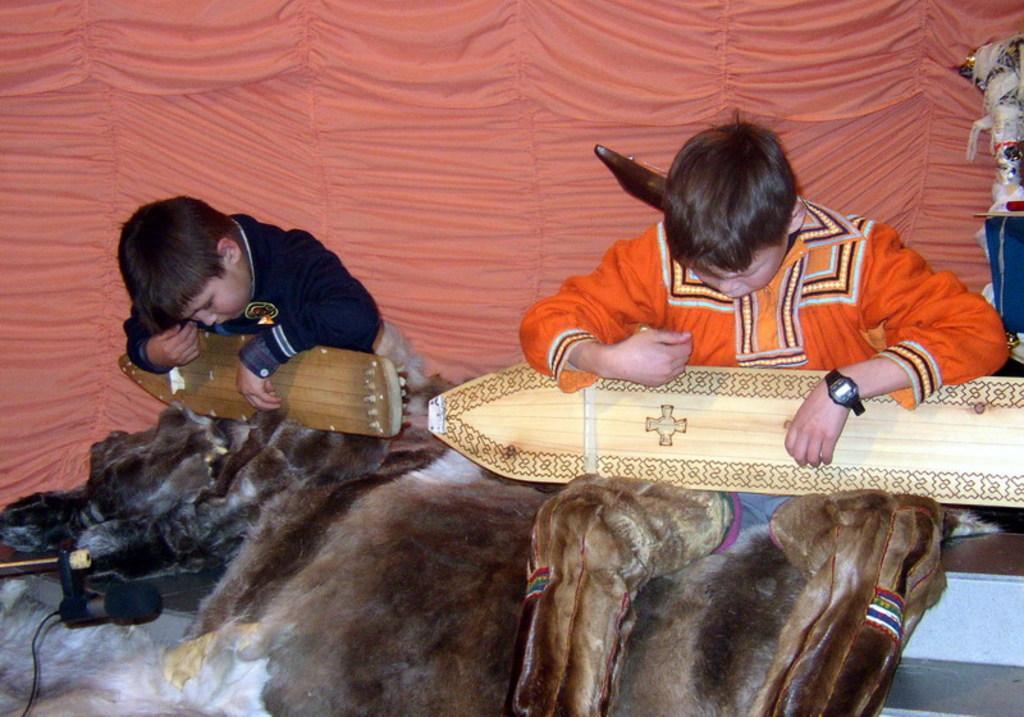Describe this image in one or two sentences. In this image, we can see two boys sitting and they are holding wooden objects. In the background, we can see the curtain and there is a microphone on the left side bottom. 